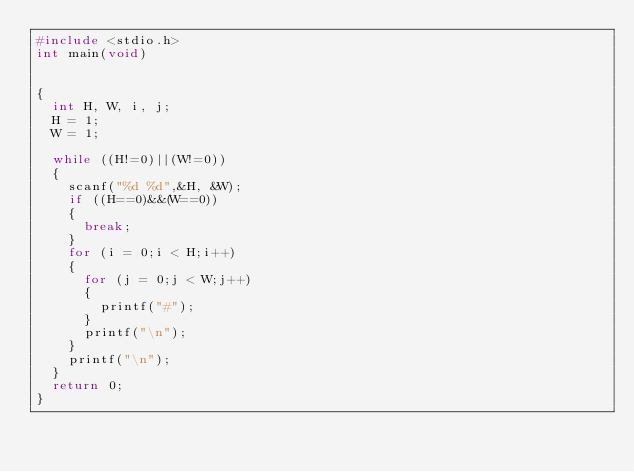Convert code to text. <code><loc_0><loc_0><loc_500><loc_500><_C_>#include <stdio.h>
int main(void)


{
	int H, W, i, j;
	H = 1;
	W = 1;
	
	while ((H!=0)||(W!=0))
	{
		scanf("%d %d",&H, &W);
		if ((H==0)&&(W==0))
		{
			break;
		}
		for (i = 0;i < H;i++)
		{
			for (j = 0;j < W;j++)
			{
				printf("#");
			}
			printf("\n");
		}
		printf("\n");
	}
	return 0;
}</code> 